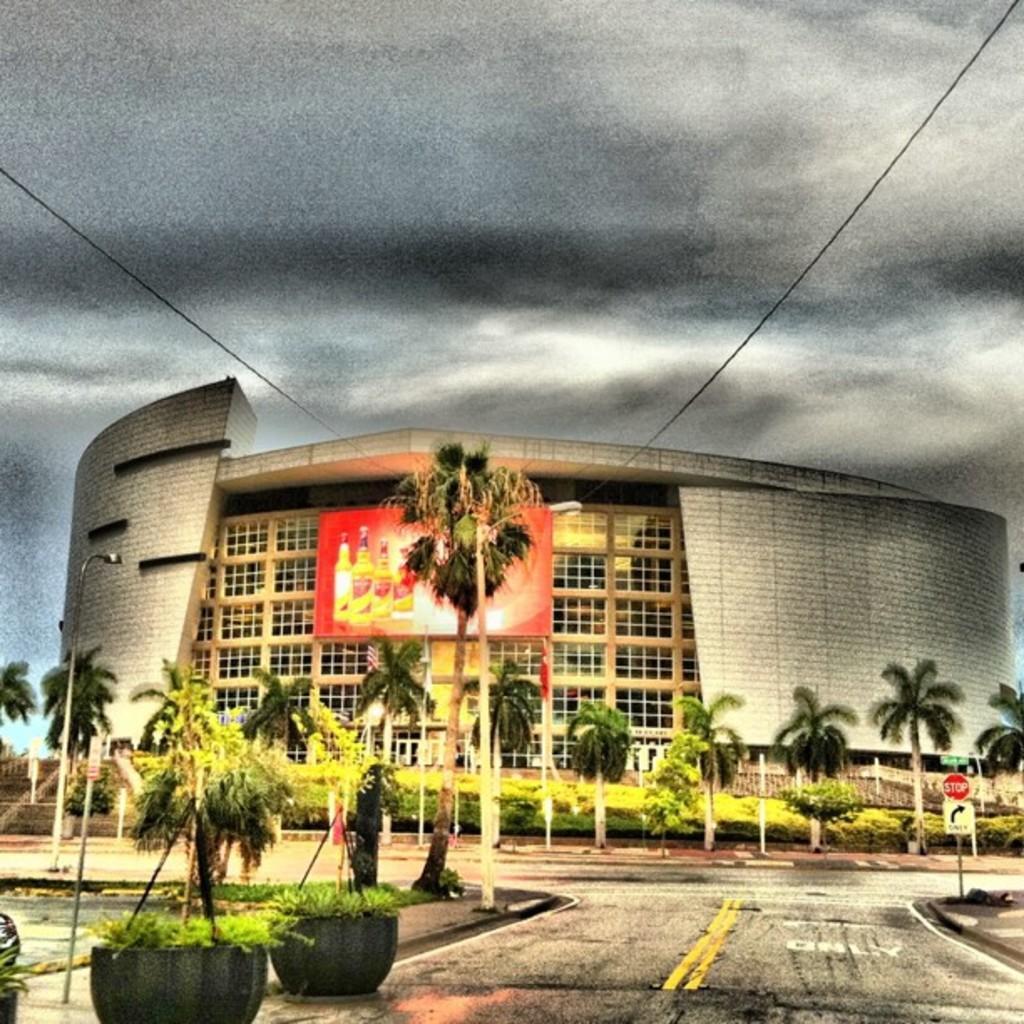Could you give a brief overview of what you see in this image? In this picture I can see a building and few trees and few plants in the pots and a sign board to the pole and a cloudy sky and we see a advertisement hoarding to the building. 